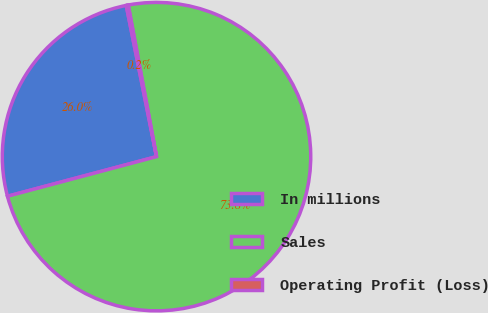Convert chart to OTSL. <chart><loc_0><loc_0><loc_500><loc_500><pie_chart><fcel>In millions<fcel>Sales<fcel>Operating Profit (Loss)<nl><fcel>25.99%<fcel>73.81%<fcel>0.21%<nl></chart> 